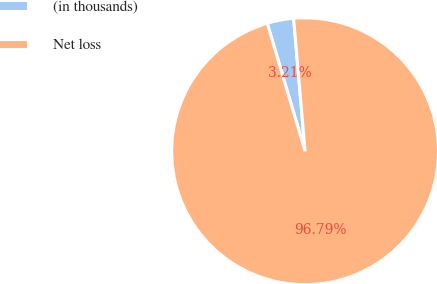Convert chart. <chart><loc_0><loc_0><loc_500><loc_500><pie_chart><fcel>(in thousands)<fcel>Net loss<nl><fcel>3.21%<fcel>96.79%<nl></chart> 